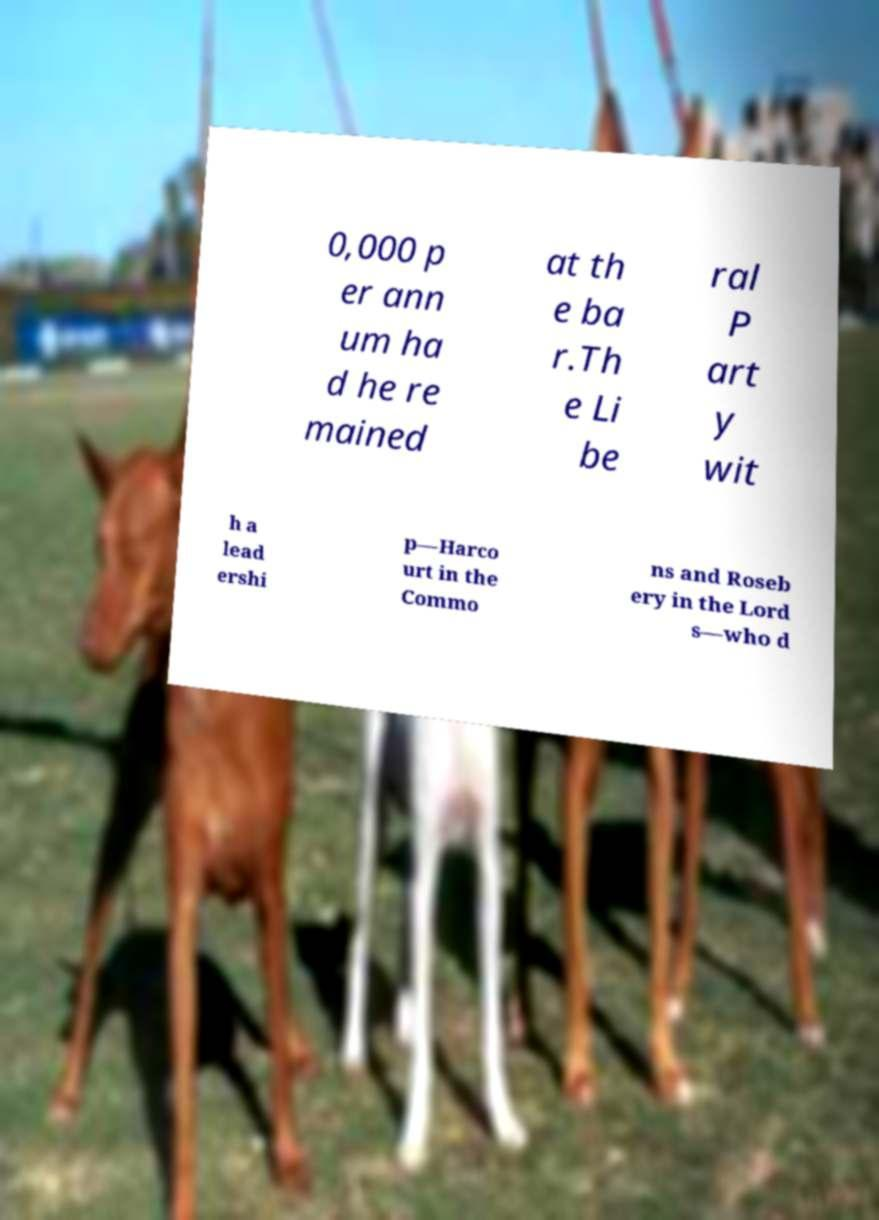There's text embedded in this image that I need extracted. Can you transcribe it verbatim? 0,000 p er ann um ha d he re mained at th e ba r.Th e Li be ral P art y wit h a lead ershi p—Harco urt in the Commo ns and Roseb ery in the Lord s—who d 